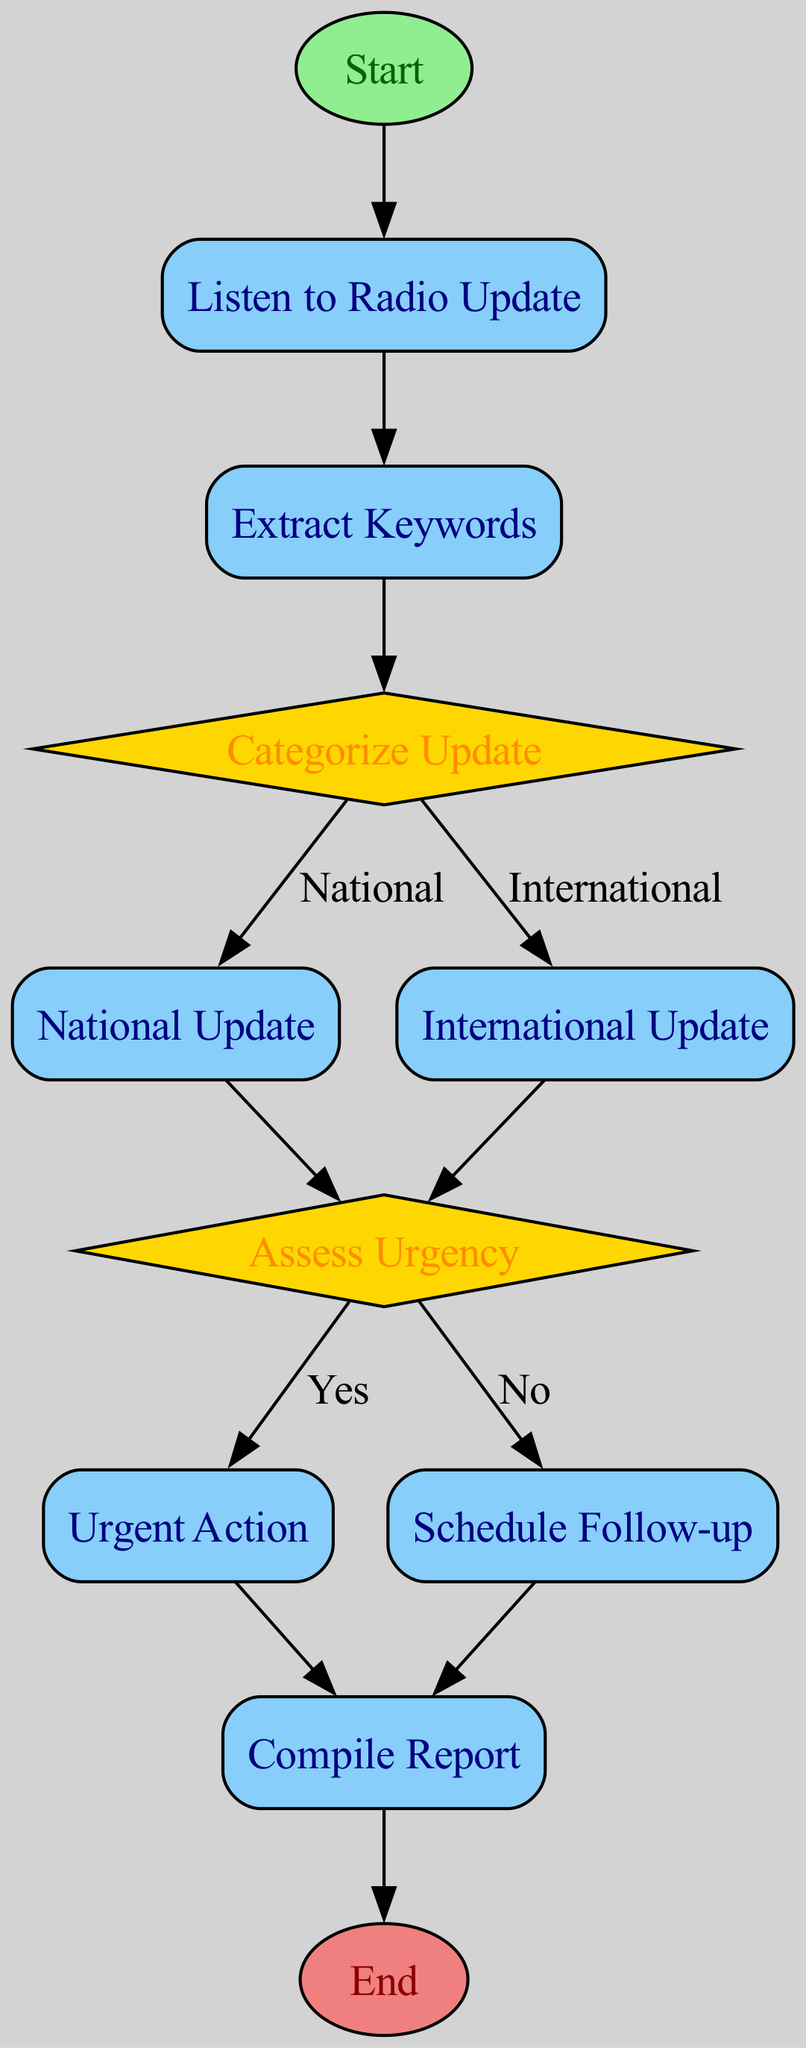What is the first step in the flowchart? The first step is labeled as “Start” and signifies the initiation of the process for analyzing radio updates regarding peace initiatives.
Answer: Start How many decision nodes are present in the diagram? The diagram contains two decision nodes: "Categorize Update" and "Assess Urgency."
Answer: 2 What is the output of the "Categorize Update" decision? The "Categorize Update" decision outputs two possible paths: one for "National Update" and another for "International Update," depending on the classification of the update.
Answer: National Update, International Update What action occurs if the urgency is assessed as 'Yes'? If the urgency is assessed as 'Yes,' the next step is "Urgent Action," which involves taking immediate steps to address the peace initiative.
Answer: Urgent Action What process follows the "Schedule Follow-up" node? After "Schedule Follow-up," the next process is "Compile Report," where documentation of the update and actions taken is carried out.
Answer: Compile Report What is the final node in the flowchart? The final node in the flowchart is labeled as “End” and signifies the conclusion of the process flow after all actions have been completed.
Answer: End If a radio update is categorized as national, what is the subsequent step? After categorizing an update as national, the next process is "National Update," which involves processing updates related to internal peace initiatives.
Answer: National Update Which decision determines if urgent action is needed? The decision that determines if urgent action is needed is "Assess Urgency." It assesses whether the peace initiative requires immediate action based on the information processed.
Answer: Assess Urgency 